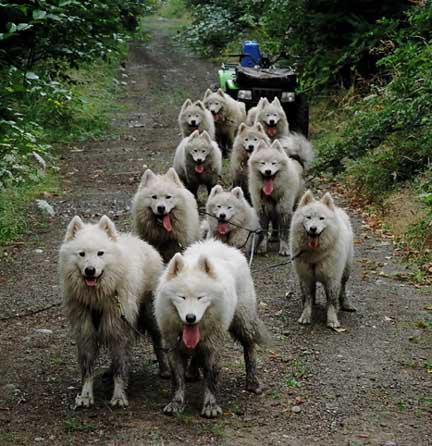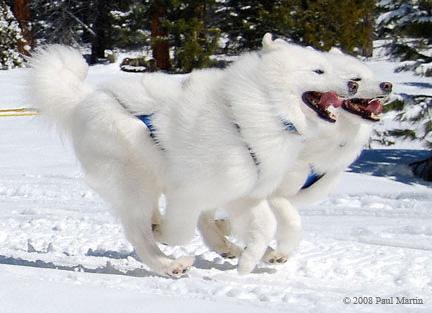The first image is the image on the left, the second image is the image on the right. Evaluate the accuracy of this statement regarding the images: "There is a man wearing red outerwear on a sled.". Is it true? Answer yes or no. No. 